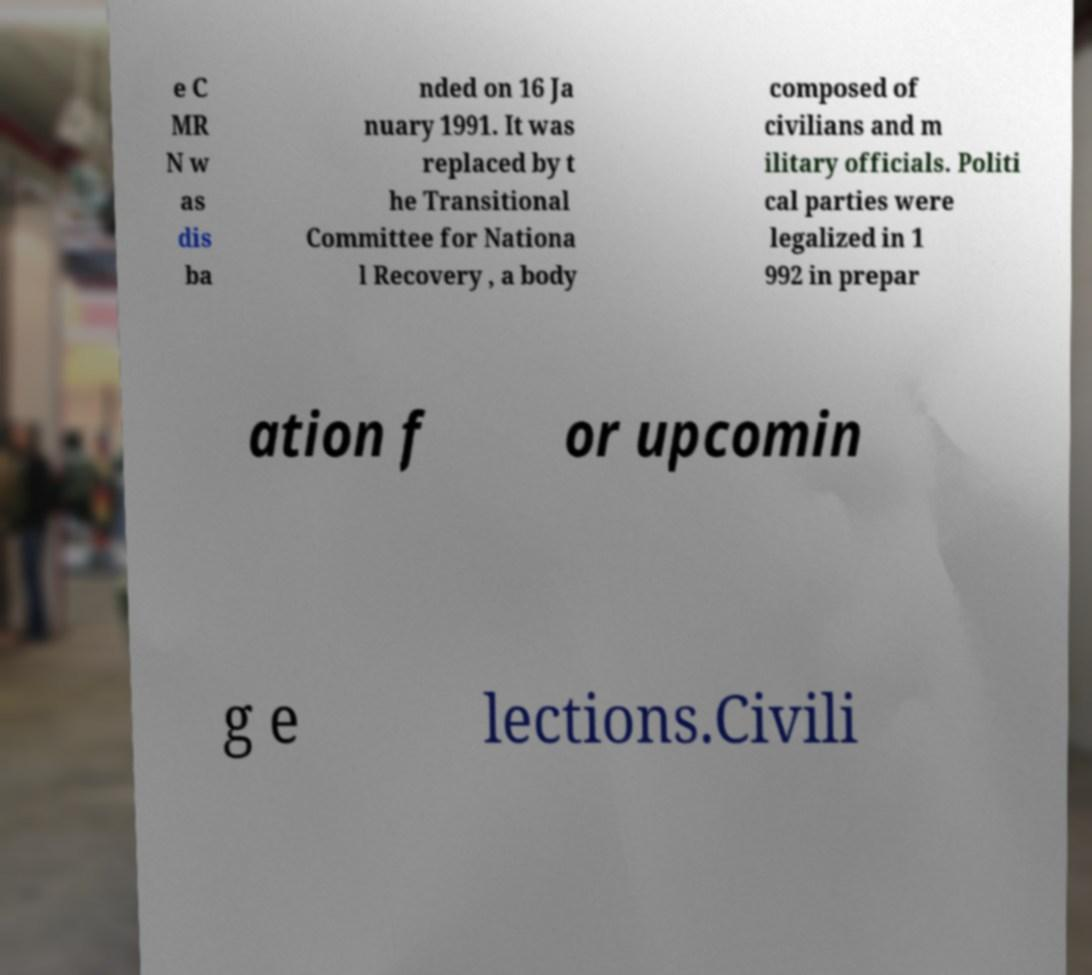Can you read and provide the text displayed in the image?This photo seems to have some interesting text. Can you extract and type it out for me? e C MR N w as dis ba nded on 16 Ja nuary 1991. It was replaced by t he Transitional Committee for Nationa l Recovery , a body composed of civilians and m ilitary officials. Politi cal parties were legalized in 1 992 in prepar ation f or upcomin g e lections.Civili 